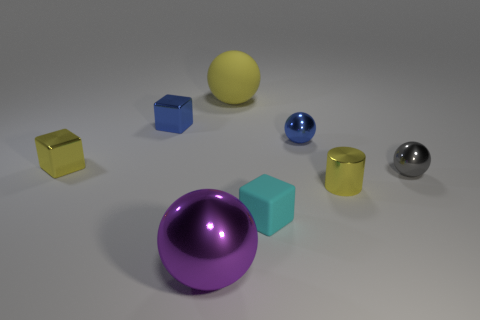How many tiny things are either gray spheres or blue cylinders?
Your answer should be compact. 1. What is the color of the big object behind the tiny blue metal thing that is to the right of the purple sphere in front of the large yellow ball?
Ensure brevity in your answer.  Yellow. What number of other objects are there of the same color as the cylinder?
Keep it short and to the point. 2. How many metal objects are either cubes or small cyan blocks?
Keep it short and to the point. 2. Is the color of the matte thing that is to the right of the large yellow sphere the same as the sphere to the right of the tiny cylinder?
Provide a succinct answer. No. Is there anything else that is made of the same material as the cyan thing?
Provide a succinct answer. Yes. The blue thing that is the same shape as the tiny cyan object is what size?
Provide a short and direct response. Small. Are there more matte spheres on the right side of the large matte sphere than small purple metal objects?
Your response must be concise. No. Is the material of the large thing that is in front of the small cyan cube the same as the gray object?
Provide a short and direct response. Yes. There is a cube right of the small blue thing that is to the left of the big object that is in front of the small cyan block; what is its size?
Ensure brevity in your answer.  Small. 